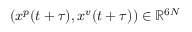<formula> <loc_0><loc_0><loc_500><loc_500>( x ^ { p } ( t + \tau ) , x ^ { v } ( t + \tau ) ) \in \mathbb { R } ^ { 6 N }</formula> 